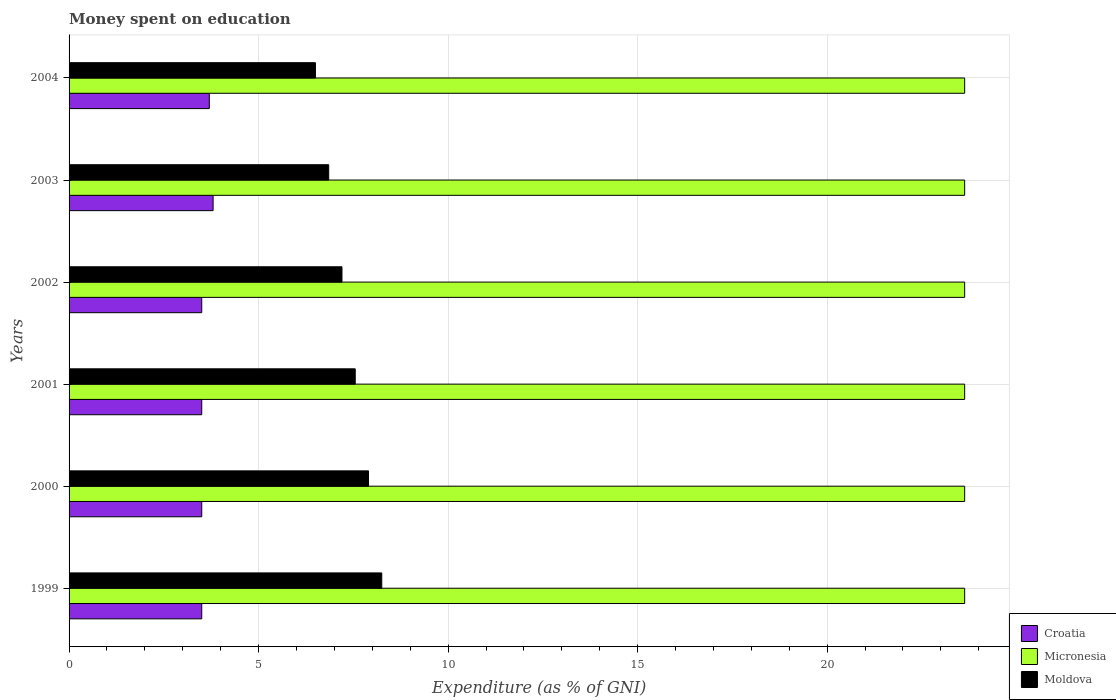How many different coloured bars are there?
Give a very brief answer. 3. Are the number of bars on each tick of the Y-axis equal?
Offer a terse response. Yes. How many bars are there on the 2nd tick from the top?
Offer a terse response. 3. What is the amount of money spent on education in Moldova in 2000?
Ensure brevity in your answer.  7.9. Across all years, what is the maximum amount of money spent on education in Micronesia?
Give a very brief answer. 23.63. Across all years, what is the minimum amount of money spent on education in Micronesia?
Keep it short and to the point. 23.63. In which year was the amount of money spent on education in Micronesia minimum?
Your answer should be compact. 1999. What is the total amount of money spent on education in Micronesia in the graph?
Ensure brevity in your answer.  141.77. What is the difference between the amount of money spent on education in Croatia in 1999 and that in 2001?
Your response must be concise. 0. What is the difference between the amount of money spent on education in Croatia in 2000 and the amount of money spent on education in Moldova in 1999?
Your answer should be compact. -4.75. What is the average amount of money spent on education in Croatia per year?
Offer a terse response. 3.58. In the year 1999, what is the difference between the amount of money spent on education in Croatia and amount of money spent on education in Moldova?
Give a very brief answer. -4.75. What is the ratio of the amount of money spent on education in Moldova in 1999 to that in 2003?
Ensure brevity in your answer.  1.2. Is the difference between the amount of money spent on education in Croatia in 2003 and 2004 greater than the difference between the amount of money spent on education in Moldova in 2003 and 2004?
Offer a terse response. No. What is the difference between the highest and the second highest amount of money spent on education in Croatia?
Offer a terse response. 0.1. What is the difference between the highest and the lowest amount of money spent on education in Moldova?
Make the answer very short. 1.75. What does the 3rd bar from the top in 2000 represents?
Ensure brevity in your answer.  Croatia. What does the 2nd bar from the bottom in 2002 represents?
Provide a short and direct response. Micronesia. How many bars are there?
Offer a very short reply. 18. Are all the bars in the graph horizontal?
Ensure brevity in your answer.  Yes. How many years are there in the graph?
Your answer should be very brief. 6. Does the graph contain any zero values?
Your response must be concise. No. Does the graph contain grids?
Provide a short and direct response. Yes. Where does the legend appear in the graph?
Your answer should be compact. Bottom right. How many legend labels are there?
Make the answer very short. 3. How are the legend labels stacked?
Provide a short and direct response. Vertical. What is the title of the graph?
Ensure brevity in your answer.  Money spent on education. Does "Kenya" appear as one of the legend labels in the graph?
Provide a succinct answer. No. What is the label or title of the X-axis?
Provide a succinct answer. Expenditure (as % of GNI). What is the label or title of the Y-axis?
Make the answer very short. Years. What is the Expenditure (as % of GNI) in Croatia in 1999?
Provide a short and direct response. 3.5. What is the Expenditure (as % of GNI) in Micronesia in 1999?
Your response must be concise. 23.63. What is the Expenditure (as % of GNI) of Moldova in 1999?
Your answer should be compact. 8.25. What is the Expenditure (as % of GNI) in Croatia in 2000?
Provide a short and direct response. 3.5. What is the Expenditure (as % of GNI) of Micronesia in 2000?
Offer a terse response. 23.63. What is the Expenditure (as % of GNI) of Moldova in 2000?
Make the answer very short. 7.9. What is the Expenditure (as % of GNI) of Croatia in 2001?
Offer a very short reply. 3.5. What is the Expenditure (as % of GNI) in Micronesia in 2001?
Ensure brevity in your answer.  23.63. What is the Expenditure (as % of GNI) of Moldova in 2001?
Provide a short and direct response. 7.55. What is the Expenditure (as % of GNI) of Micronesia in 2002?
Ensure brevity in your answer.  23.63. What is the Expenditure (as % of GNI) of Moldova in 2002?
Offer a terse response. 7.2. What is the Expenditure (as % of GNI) in Croatia in 2003?
Offer a terse response. 3.8. What is the Expenditure (as % of GNI) in Micronesia in 2003?
Your response must be concise. 23.63. What is the Expenditure (as % of GNI) in Moldova in 2003?
Provide a short and direct response. 6.85. What is the Expenditure (as % of GNI) in Croatia in 2004?
Provide a short and direct response. 3.7. What is the Expenditure (as % of GNI) of Micronesia in 2004?
Make the answer very short. 23.63. What is the Expenditure (as % of GNI) of Moldova in 2004?
Ensure brevity in your answer.  6.5. Across all years, what is the maximum Expenditure (as % of GNI) of Micronesia?
Ensure brevity in your answer.  23.63. Across all years, what is the maximum Expenditure (as % of GNI) in Moldova?
Your answer should be compact. 8.25. Across all years, what is the minimum Expenditure (as % of GNI) in Croatia?
Provide a short and direct response. 3.5. Across all years, what is the minimum Expenditure (as % of GNI) of Micronesia?
Provide a short and direct response. 23.63. Across all years, what is the minimum Expenditure (as % of GNI) in Moldova?
Your answer should be compact. 6.5. What is the total Expenditure (as % of GNI) of Croatia in the graph?
Offer a terse response. 21.5. What is the total Expenditure (as % of GNI) of Micronesia in the graph?
Provide a short and direct response. 141.77. What is the total Expenditure (as % of GNI) of Moldova in the graph?
Offer a very short reply. 44.25. What is the difference between the Expenditure (as % of GNI) in Croatia in 1999 and that in 2000?
Your answer should be very brief. 0. What is the difference between the Expenditure (as % of GNI) of Micronesia in 1999 and that in 2000?
Keep it short and to the point. 0. What is the difference between the Expenditure (as % of GNI) of Croatia in 1999 and that in 2001?
Provide a succinct answer. 0. What is the difference between the Expenditure (as % of GNI) of Micronesia in 1999 and that in 2001?
Provide a succinct answer. 0. What is the difference between the Expenditure (as % of GNI) of Croatia in 1999 and that in 2002?
Give a very brief answer. 0. What is the difference between the Expenditure (as % of GNI) in Micronesia in 1999 and that in 2002?
Ensure brevity in your answer.  0. What is the difference between the Expenditure (as % of GNI) in Moldova in 1999 and that in 2002?
Give a very brief answer. 1.05. What is the difference between the Expenditure (as % of GNI) of Micronesia in 1999 and that in 2003?
Keep it short and to the point. 0. What is the difference between the Expenditure (as % of GNI) of Moldova in 1999 and that in 2003?
Provide a short and direct response. 1.4. What is the difference between the Expenditure (as % of GNI) of Croatia in 1999 and that in 2004?
Offer a terse response. -0.2. What is the difference between the Expenditure (as % of GNI) of Micronesia in 1999 and that in 2004?
Ensure brevity in your answer.  0. What is the difference between the Expenditure (as % of GNI) in Croatia in 2000 and that in 2002?
Offer a very short reply. 0. What is the difference between the Expenditure (as % of GNI) of Moldova in 2000 and that in 2002?
Give a very brief answer. 0.7. What is the difference between the Expenditure (as % of GNI) of Moldova in 2000 and that in 2003?
Offer a terse response. 1.05. What is the difference between the Expenditure (as % of GNI) of Micronesia in 2000 and that in 2004?
Give a very brief answer. 0. What is the difference between the Expenditure (as % of GNI) in Moldova in 2000 and that in 2004?
Your answer should be very brief. 1.4. What is the difference between the Expenditure (as % of GNI) of Croatia in 2001 and that in 2002?
Give a very brief answer. 0. What is the difference between the Expenditure (as % of GNI) in Moldova in 2001 and that in 2002?
Your answer should be compact. 0.35. What is the difference between the Expenditure (as % of GNI) in Croatia in 2001 and that in 2003?
Provide a short and direct response. -0.3. What is the difference between the Expenditure (as % of GNI) of Croatia in 2001 and that in 2004?
Your response must be concise. -0.2. What is the difference between the Expenditure (as % of GNI) in Moldova in 2001 and that in 2004?
Offer a terse response. 1.05. What is the difference between the Expenditure (as % of GNI) in Croatia in 2002 and that in 2003?
Your answer should be compact. -0.3. What is the difference between the Expenditure (as % of GNI) in Micronesia in 2002 and that in 2003?
Provide a short and direct response. 0. What is the difference between the Expenditure (as % of GNI) of Micronesia in 2002 and that in 2004?
Your answer should be compact. 0. What is the difference between the Expenditure (as % of GNI) of Moldova in 2002 and that in 2004?
Give a very brief answer. 0.7. What is the difference between the Expenditure (as % of GNI) of Croatia in 2003 and that in 2004?
Offer a very short reply. 0.1. What is the difference between the Expenditure (as % of GNI) in Micronesia in 2003 and that in 2004?
Offer a very short reply. 0. What is the difference between the Expenditure (as % of GNI) of Moldova in 2003 and that in 2004?
Your answer should be very brief. 0.35. What is the difference between the Expenditure (as % of GNI) of Croatia in 1999 and the Expenditure (as % of GNI) of Micronesia in 2000?
Provide a short and direct response. -20.13. What is the difference between the Expenditure (as % of GNI) of Croatia in 1999 and the Expenditure (as % of GNI) of Moldova in 2000?
Provide a short and direct response. -4.4. What is the difference between the Expenditure (as % of GNI) in Micronesia in 1999 and the Expenditure (as % of GNI) in Moldova in 2000?
Keep it short and to the point. 15.73. What is the difference between the Expenditure (as % of GNI) of Croatia in 1999 and the Expenditure (as % of GNI) of Micronesia in 2001?
Offer a terse response. -20.13. What is the difference between the Expenditure (as % of GNI) of Croatia in 1999 and the Expenditure (as % of GNI) of Moldova in 2001?
Keep it short and to the point. -4.05. What is the difference between the Expenditure (as % of GNI) in Micronesia in 1999 and the Expenditure (as % of GNI) in Moldova in 2001?
Your response must be concise. 16.08. What is the difference between the Expenditure (as % of GNI) in Croatia in 1999 and the Expenditure (as % of GNI) in Micronesia in 2002?
Offer a very short reply. -20.13. What is the difference between the Expenditure (as % of GNI) in Micronesia in 1999 and the Expenditure (as % of GNI) in Moldova in 2002?
Offer a terse response. 16.43. What is the difference between the Expenditure (as % of GNI) in Croatia in 1999 and the Expenditure (as % of GNI) in Micronesia in 2003?
Your answer should be compact. -20.13. What is the difference between the Expenditure (as % of GNI) of Croatia in 1999 and the Expenditure (as % of GNI) of Moldova in 2003?
Your answer should be very brief. -3.35. What is the difference between the Expenditure (as % of GNI) of Micronesia in 1999 and the Expenditure (as % of GNI) of Moldova in 2003?
Provide a succinct answer. 16.78. What is the difference between the Expenditure (as % of GNI) of Croatia in 1999 and the Expenditure (as % of GNI) of Micronesia in 2004?
Your response must be concise. -20.13. What is the difference between the Expenditure (as % of GNI) of Croatia in 1999 and the Expenditure (as % of GNI) of Moldova in 2004?
Provide a short and direct response. -3. What is the difference between the Expenditure (as % of GNI) in Micronesia in 1999 and the Expenditure (as % of GNI) in Moldova in 2004?
Provide a short and direct response. 17.13. What is the difference between the Expenditure (as % of GNI) in Croatia in 2000 and the Expenditure (as % of GNI) in Micronesia in 2001?
Provide a succinct answer. -20.13. What is the difference between the Expenditure (as % of GNI) in Croatia in 2000 and the Expenditure (as % of GNI) in Moldova in 2001?
Provide a short and direct response. -4.05. What is the difference between the Expenditure (as % of GNI) of Micronesia in 2000 and the Expenditure (as % of GNI) of Moldova in 2001?
Your response must be concise. 16.08. What is the difference between the Expenditure (as % of GNI) in Croatia in 2000 and the Expenditure (as % of GNI) in Micronesia in 2002?
Provide a short and direct response. -20.13. What is the difference between the Expenditure (as % of GNI) of Croatia in 2000 and the Expenditure (as % of GNI) of Moldova in 2002?
Provide a succinct answer. -3.7. What is the difference between the Expenditure (as % of GNI) of Micronesia in 2000 and the Expenditure (as % of GNI) of Moldova in 2002?
Keep it short and to the point. 16.43. What is the difference between the Expenditure (as % of GNI) in Croatia in 2000 and the Expenditure (as % of GNI) in Micronesia in 2003?
Your answer should be compact. -20.13. What is the difference between the Expenditure (as % of GNI) of Croatia in 2000 and the Expenditure (as % of GNI) of Moldova in 2003?
Keep it short and to the point. -3.35. What is the difference between the Expenditure (as % of GNI) of Micronesia in 2000 and the Expenditure (as % of GNI) of Moldova in 2003?
Make the answer very short. 16.78. What is the difference between the Expenditure (as % of GNI) in Croatia in 2000 and the Expenditure (as % of GNI) in Micronesia in 2004?
Provide a succinct answer. -20.13. What is the difference between the Expenditure (as % of GNI) of Micronesia in 2000 and the Expenditure (as % of GNI) of Moldova in 2004?
Provide a short and direct response. 17.13. What is the difference between the Expenditure (as % of GNI) of Croatia in 2001 and the Expenditure (as % of GNI) of Micronesia in 2002?
Your answer should be very brief. -20.13. What is the difference between the Expenditure (as % of GNI) of Micronesia in 2001 and the Expenditure (as % of GNI) of Moldova in 2002?
Give a very brief answer. 16.43. What is the difference between the Expenditure (as % of GNI) in Croatia in 2001 and the Expenditure (as % of GNI) in Micronesia in 2003?
Provide a succinct answer. -20.13. What is the difference between the Expenditure (as % of GNI) in Croatia in 2001 and the Expenditure (as % of GNI) in Moldova in 2003?
Your answer should be compact. -3.35. What is the difference between the Expenditure (as % of GNI) of Micronesia in 2001 and the Expenditure (as % of GNI) of Moldova in 2003?
Provide a short and direct response. 16.78. What is the difference between the Expenditure (as % of GNI) in Croatia in 2001 and the Expenditure (as % of GNI) in Micronesia in 2004?
Your answer should be very brief. -20.13. What is the difference between the Expenditure (as % of GNI) in Croatia in 2001 and the Expenditure (as % of GNI) in Moldova in 2004?
Your answer should be very brief. -3. What is the difference between the Expenditure (as % of GNI) in Micronesia in 2001 and the Expenditure (as % of GNI) in Moldova in 2004?
Keep it short and to the point. 17.13. What is the difference between the Expenditure (as % of GNI) of Croatia in 2002 and the Expenditure (as % of GNI) of Micronesia in 2003?
Offer a terse response. -20.13. What is the difference between the Expenditure (as % of GNI) of Croatia in 2002 and the Expenditure (as % of GNI) of Moldova in 2003?
Provide a short and direct response. -3.35. What is the difference between the Expenditure (as % of GNI) in Micronesia in 2002 and the Expenditure (as % of GNI) in Moldova in 2003?
Give a very brief answer. 16.78. What is the difference between the Expenditure (as % of GNI) in Croatia in 2002 and the Expenditure (as % of GNI) in Micronesia in 2004?
Offer a terse response. -20.13. What is the difference between the Expenditure (as % of GNI) in Croatia in 2002 and the Expenditure (as % of GNI) in Moldova in 2004?
Ensure brevity in your answer.  -3. What is the difference between the Expenditure (as % of GNI) of Micronesia in 2002 and the Expenditure (as % of GNI) of Moldova in 2004?
Keep it short and to the point. 17.13. What is the difference between the Expenditure (as % of GNI) in Croatia in 2003 and the Expenditure (as % of GNI) in Micronesia in 2004?
Give a very brief answer. -19.83. What is the difference between the Expenditure (as % of GNI) of Micronesia in 2003 and the Expenditure (as % of GNI) of Moldova in 2004?
Your response must be concise. 17.13. What is the average Expenditure (as % of GNI) of Croatia per year?
Give a very brief answer. 3.58. What is the average Expenditure (as % of GNI) of Micronesia per year?
Ensure brevity in your answer.  23.63. What is the average Expenditure (as % of GNI) in Moldova per year?
Ensure brevity in your answer.  7.38. In the year 1999, what is the difference between the Expenditure (as % of GNI) in Croatia and Expenditure (as % of GNI) in Micronesia?
Provide a short and direct response. -20.13. In the year 1999, what is the difference between the Expenditure (as % of GNI) in Croatia and Expenditure (as % of GNI) in Moldova?
Offer a very short reply. -4.75. In the year 1999, what is the difference between the Expenditure (as % of GNI) of Micronesia and Expenditure (as % of GNI) of Moldova?
Give a very brief answer. 15.38. In the year 2000, what is the difference between the Expenditure (as % of GNI) in Croatia and Expenditure (as % of GNI) in Micronesia?
Your answer should be very brief. -20.13. In the year 2000, what is the difference between the Expenditure (as % of GNI) of Micronesia and Expenditure (as % of GNI) of Moldova?
Give a very brief answer. 15.73. In the year 2001, what is the difference between the Expenditure (as % of GNI) of Croatia and Expenditure (as % of GNI) of Micronesia?
Your answer should be compact. -20.13. In the year 2001, what is the difference between the Expenditure (as % of GNI) of Croatia and Expenditure (as % of GNI) of Moldova?
Offer a terse response. -4.05. In the year 2001, what is the difference between the Expenditure (as % of GNI) of Micronesia and Expenditure (as % of GNI) of Moldova?
Provide a short and direct response. 16.08. In the year 2002, what is the difference between the Expenditure (as % of GNI) in Croatia and Expenditure (as % of GNI) in Micronesia?
Provide a succinct answer. -20.13. In the year 2002, what is the difference between the Expenditure (as % of GNI) of Croatia and Expenditure (as % of GNI) of Moldova?
Offer a terse response. -3.7. In the year 2002, what is the difference between the Expenditure (as % of GNI) of Micronesia and Expenditure (as % of GNI) of Moldova?
Provide a short and direct response. 16.43. In the year 2003, what is the difference between the Expenditure (as % of GNI) in Croatia and Expenditure (as % of GNI) in Micronesia?
Provide a short and direct response. -19.83. In the year 2003, what is the difference between the Expenditure (as % of GNI) of Croatia and Expenditure (as % of GNI) of Moldova?
Ensure brevity in your answer.  -3.05. In the year 2003, what is the difference between the Expenditure (as % of GNI) of Micronesia and Expenditure (as % of GNI) of Moldova?
Offer a terse response. 16.78. In the year 2004, what is the difference between the Expenditure (as % of GNI) in Croatia and Expenditure (as % of GNI) in Micronesia?
Ensure brevity in your answer.  -19.93. In the year 2004, what is the difference between the Expenditure (as % of GNI) in Micronesia and Expenditure (as % of GNI) in Moldova?
Offer a terse response. 17.13. What is the ratio of the Expenditure (as % of GNI) in Croatia in 1999 to that in 2000?
Your response must be concise. 1. What is the ratio of the Expenditure (as % of GNI) in Micronesia in 1999 to that in 2000?
Offer a terse response. 1. What is the ratio of the Expenditure (as % of GNI) of Moldova in 1999 to that in 2000?
Give a very brief answer. 1.04. What is the ratio of the Expenditure (as % of GNI) of Micronesia in 1999 to that in 2001?
Keep it short and to the point. 1. What is the ratio of the Expenditure (as % of GNI) of Moldova in 1999 to that in 2001?
Your answer should be very brief. 1.09. What is the ratio of the Expenditure (as % of GNI) of Croatia in 1999 to that in 2002?
Your response must be concise. 1. What is the ratio of the Expenditure (as % of GNI) in Micronesia in 1999 to that in 2002?
Provide a short and direct response. 1. What is the ratio of the Expenditure (as % of GNI) in Moldova in 1999 to that in 2002?
Provide a succinct answer. 1.15. What is the ratio of the Expenditure (as % of GNI) in Croatia in 1999 to that in 2003?
Provide a succinct answer. 0.92. What is the ratio of the Expenditure (as % of GNI) in Micronesia in 1999 to that in 2003?
Ensure brevity in your answer.  1. What is the ratio of the Expenditure (as % of GNI) in Moldova in 1999 to that in 2003?
Your answer should be compact. 1.2. What is the ratio of the Expenditure (as % of GNI) of Croatia in 1999 to that in 2004?
Make the answer very short. 0.95. What is the ratio of the Expenditure (as % of GNI) of Micronesia in 1999 to that in 2004?
Provide a succinct answer. 1. What is the ratio of the Expenditure (as % of GNI) in Moldova in 1999 to that in 2004?
Offer a terse response. 1.27. What is the ratio of the Expenditure (as % of GNI) of Croatia in 2000 to that in 2001?
Provide a short and direct response. 1. What is the ratio of the Expenditure (as % of GNI) of Moldova in 2000 to that in 2001?
Keep it short and to the point. 1.05. What is the ratio of the Expenditure (as % of GNI) of Micronesia in 2000 to that in 2002?
Provide a short and direct response. 1. What is the ratio of the Expenditure (as % of GNI) of Moldova in 2000 to that in 2002?
Your answer should be very brief. 1.1. What is the ratio of the Expenditure (as % of GNI) in Croatia in 2000 to that in 2003?
Your answer should be very brief. 0.92. What is the ratio of the Expenditure (as % of GNI) of Moldova in 2000 to that in 2003?
Keep it short and to the point. 1.15. What is the ratio of the Expenditure (as % of GNI) in Croatia in 2000 to that in 2004?
Offer a very short reply. 0.95. What is the ratio of the Expenditure (as % of GNI) of Micronesia in 2000 to that in 2004?
Offer a terse response. 1. What is the ratio of the Expenditure (as % of GNI) in Moldova in 2000 to that in 2004?
Provide a succinct answer. 1.22. What is the ratio of the Expenditure (as % of GNI) of Micronesia in 2001 to that in 2002?
Make the answer very short. 1. What is the ratio of the Expenditure (as % of GNI) of Moldova in 2001 to that in 2002?
Keep it short and to the point. 1.05. What is the ratio of the Expenditure (as % of GNI) of Croatia in 2001 to that in 2003?
Provide a short and direct response. 0.92. What is the ratio of the Expenditure (as % of GNI) in Micronesia in 2001 to that in 2003?
Ensure brevity in your answer.  1. What is the ratio of the Expenditure (as % of GNI) in Moldova in 2001 to that in 2003?
Make the answer very short. 1.1. What is the ratio of the Expenditure (as % of GNI) in Croatia in 2001 to that in 2004?
Offer a terse response. 0.95. What is the ratio of the Expenditure (as % of GNI) of Moldova in 2001 to that in 2004?
Ensure brevity in your answer.  1.16. What is the ratio of the Expenditure (as % of GNI) in Croatia in 2002 to that in 2003?
Provide a succinct answer. 0.92. What is the ratio of the Expenditure (as % of GNI) of Micronesia in 2002 to that in 2003?
Offer a very short reply. 1. What is the ratio of the Expenditure (as % of GNI) of Moldova in 2002 to that in 2003?
Your answer should be compact. 1.05. What is the ratio of the Expenditure (as % of GNI) in Croatia in 2002 to that in 2004?
Give a very brief answer. 0.95. What is the ratio of the Expenditure (as % of GNI) in Moldova in 2002 to that in 2004?
Your answer should be compact. 1.11. What is the ratio of the Expenditure (as % of GNI) of Micronesia in 2003 to that in 2004?
Keep it short and to the point. 1. What is the ratio of the Expenditure (as % of GNI) in Moldova in 2003 to that in 2004?
Keep it short and to the point. 1.05. What is the difference between the highest and the second highest Expenditure (as % of GNI) of Croatia?
Make the answer very short. 0.1. What is the difference between the highest and the second highest Expenditure (as % of GNI) in Moldova?
Provide a succinct answer. 0.35. What is the difference between the highest and the lowest Expenditure (as % of GNI) of Micronesia?
Provide a succinct answer. 0. What is the difference between the highest and the lowest Expenditure (as % of GNI) of Moldova?
Your response must be concise. 1.75. 